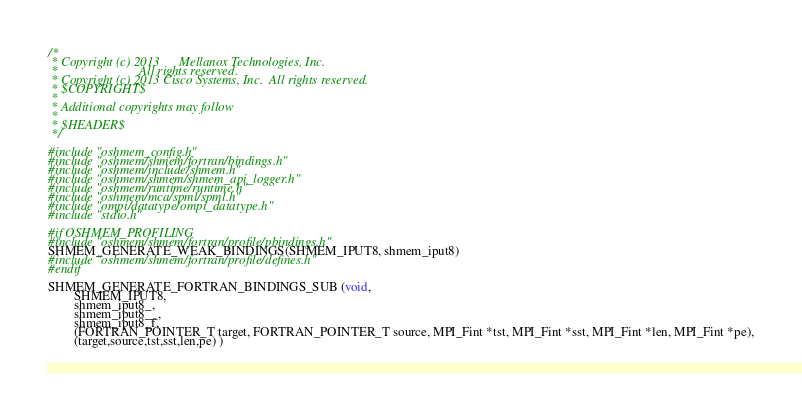<code> <loc_0><loc_0><loc_500><loc_500><_C_>/*
 * Copyright (c) 2013      Mellanox Technologies, Inc.
 *                         All rights reserved.
 * Copyright (c) 2013 Cisco Systems, Inc.  All rights reserved.
 * $COPYRIGHT$
 *
 * Additional copyrights may follow
 *
 * $HEADER$
 */

#include "oshmem_config.h"
#include "oshmem/shmem/fortran/bindings.h"
#include "oshmem/include/shmem.h"
#include "oshmem/shmem/shmem_api_logger.h"
#include "oshmem/runtime/runtime.h"
#include "oshmem/mca/spml/spml.h"
#include "ompi/datatype/ompi_datatype.h"
#include "stdio.h"

#if OSHMEM_PROFILING
#include "oshmem/shmem/fortran/profile/pbindings.h"
SHMEM_GENERATE_WEAK_BINDINGS(SHMEM_IPUT8, shmem_iput8)
#include "oshmem/shmem/fortran/profile/defines.h"
#endif

SHMEM_GENERATE_FORTRAN_BINDINGS_SUB (void,
        SHMEM_IPUT8,
        shmem_iput8_,
        shmem_iput8__,
        shmem_iput8_f,
        (FORTRAN_POINTER_T target, FORTRAN_POINTER_T source, MPI_Fint *tst, MPI_Fint *sst, MPI_Fint *len, MPI_Fint *pe),
        (target,source,tst,sst,len,pe) )
</code> 